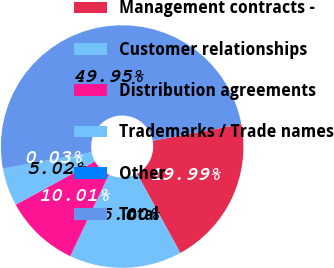Convert chart to OTSL. <chart><loc_0><loc_0><loc_500><loc_500><pie_chart><fcel>Management contracts -<fcel>Customer relationships<fcel>Distribution agreements<fcel>Trademarks / Trade names<fcel>Other<fcel>Total<nl><fcel>19.99%<fcel>15.0%<fcel>10.01%<fcel>5.02%<fcel>0.03%<fcel>49.95%<nl></chart> 